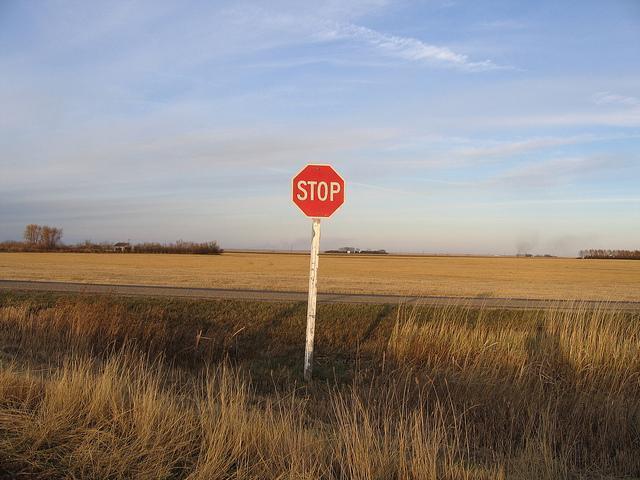How many dogs are there?
Give a very brief answer. 0. 